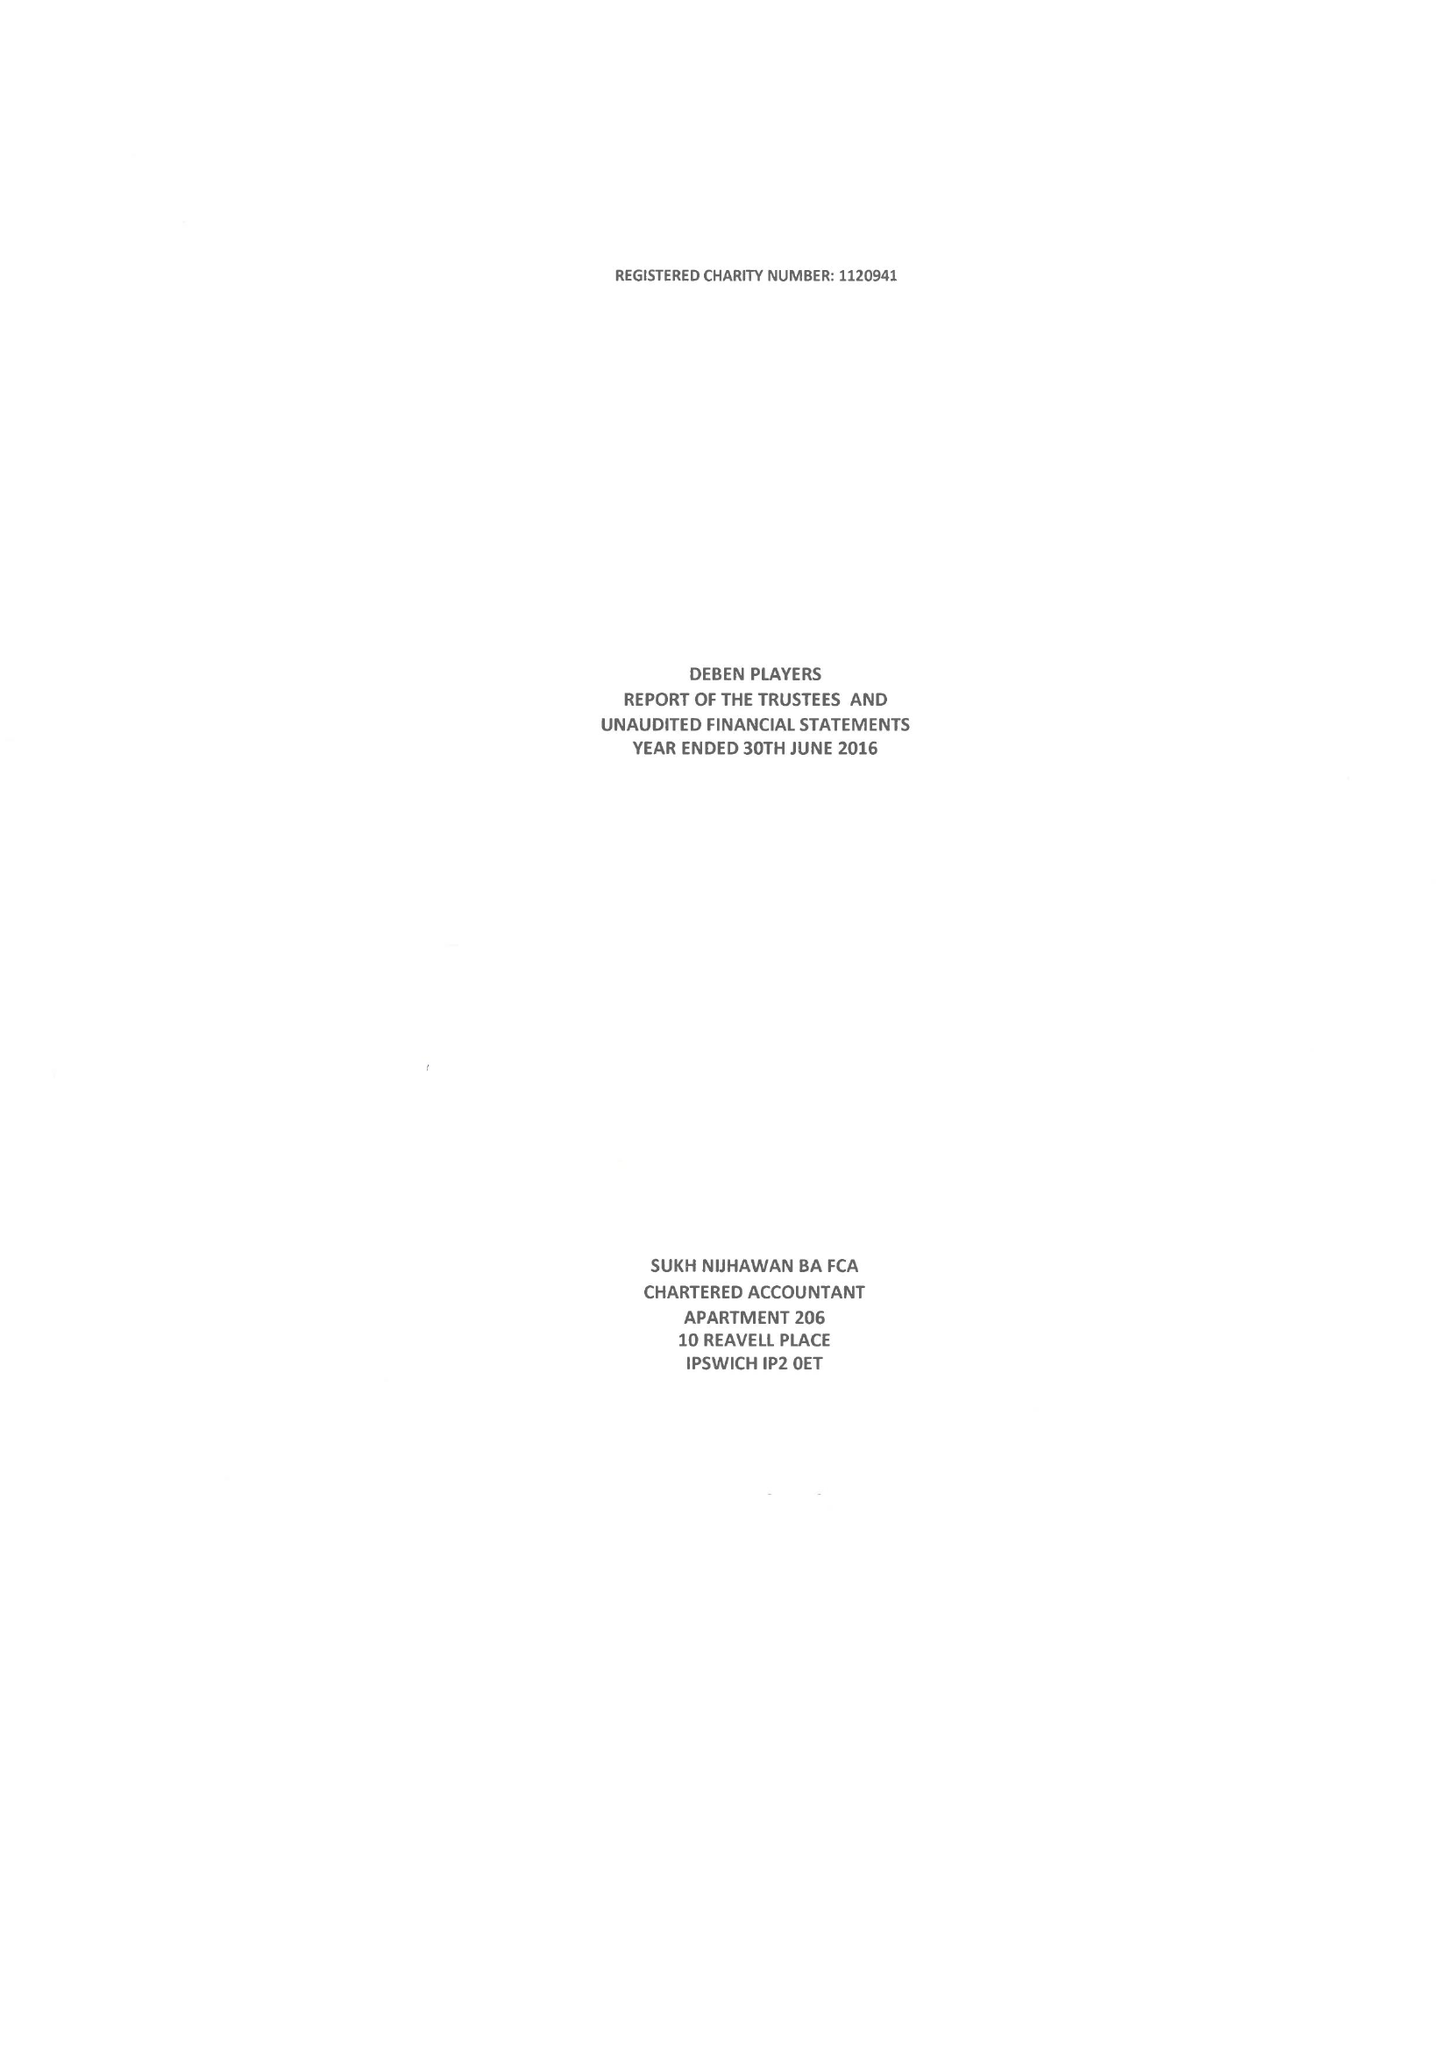What is the value for the charity_number?
Answer the question using a single word or phrase. 1120941 